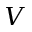Convert formula to latex. <formula><loc_0><loc_0><loc_500><loc_500>V</formula> 